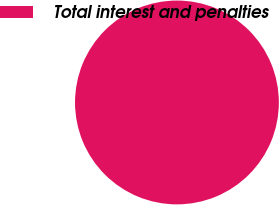Convert chart. <chart><loc_0><loc_0><loc_500><loc_500><pie_chart><fcel>Total interest and penalties<nl><fcel>100.0%<nl></chart> 